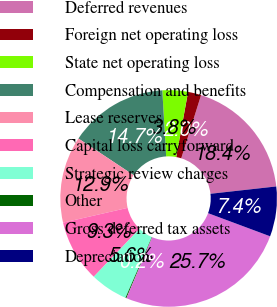<chart> <loc_0><loc_0><loc_500><loc_500><pie_chart><fcel>Deferred revenues<fcel>Foreign net operating loss<fcel>State net operating loss<fcel>Compensation and benefits<fcel>Lease reserves<fcel>Capital loss carryforward<fcel>Strategic review charges<fcel>Other<fcel>Gross deferred tax assets<fcel>Depreciation<nl><fcel>18.39%<fcel>1.97%<fcel>3.8%<fcel>14.74%<fcel>12.92%<fcel>9.27%<fcel>5.62%<fcel>0.15%<fcel>25.69%<fcel>7.45%<nl></chart> 